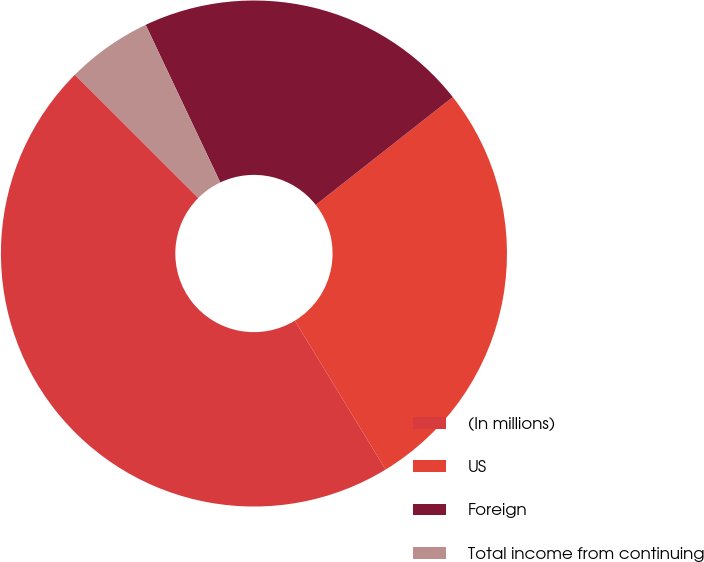Convert chart to OTSL. <chart><loc_0><loc_0><loc_500><loc_500><pie_chart><fcel>(In millions)<fcel>US<fcel>Foreign<fcel>Total income from continuing<nl><fcel>46.2%<fcel>26.9%<fcel>21.43%<fcel>5.47%<nl></chart> 